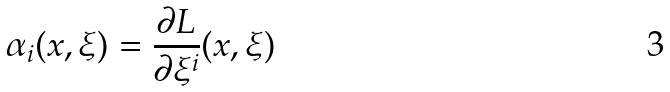<formula> <loc_0><loc_0><loc_500><loc_500>\alpha _ { i } ( x , \xi ) = \frac { \partial L } { \partial \xi ^ { i } } ( x , \xi )</formula> 